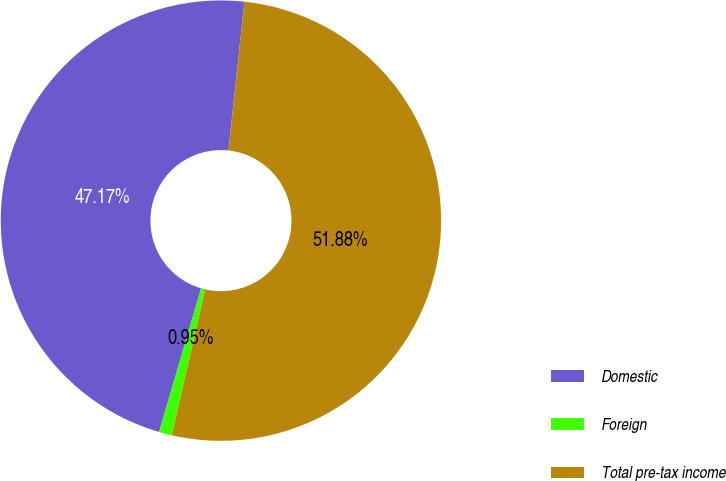Convert chart to OTSL. <chart><loc_0><loc_0><loc_500><loc_500><pie_chart><fcel>Domestic<fcel>Foreign<fcel>Total pre-tax income<nl><fcel>47.17%<fcel>0.95%<fcel>51.88%<nl></chart> 